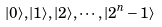Convert formula to latex. <formula><loc_0><loc_0><loc_500><loc_500>| 0 \rangle , | 1 \rangle , | 2 \rangle , \cdots , | 2 ^ { n } - 1 \rangle</formula> 